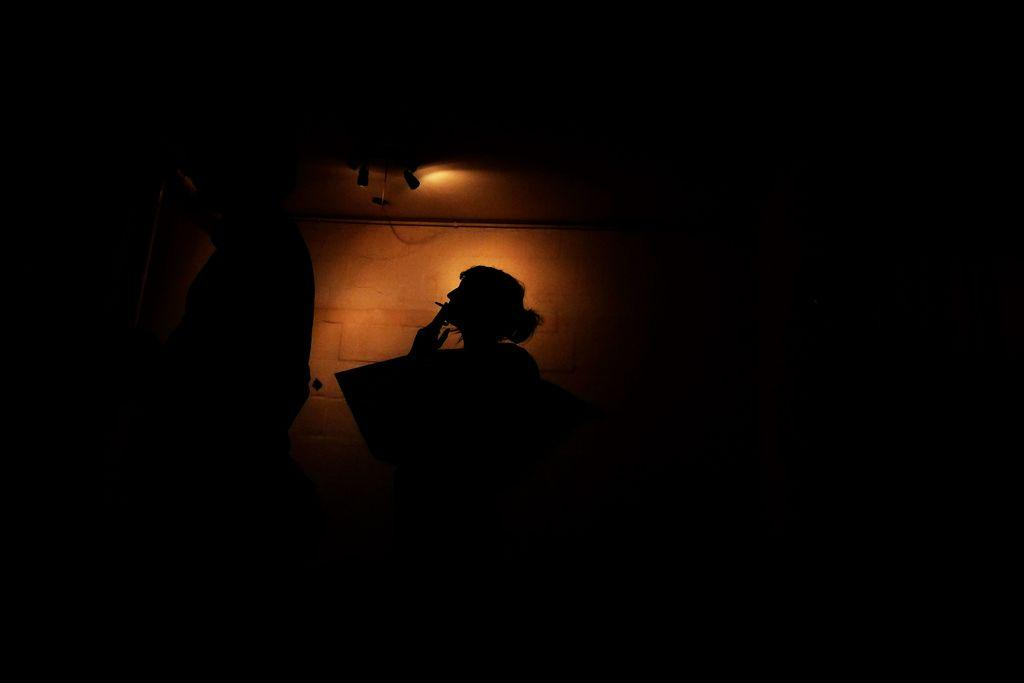How many people are in the image? There are two persons in the image. What can be seen in the image besides the people? There are lights visible in the image. What is the color of the background in the image? The background of the image is dark. What type of nut is being cracked on the throne in the image? There is no throne or nut present in the image; it features two persons and lights. 